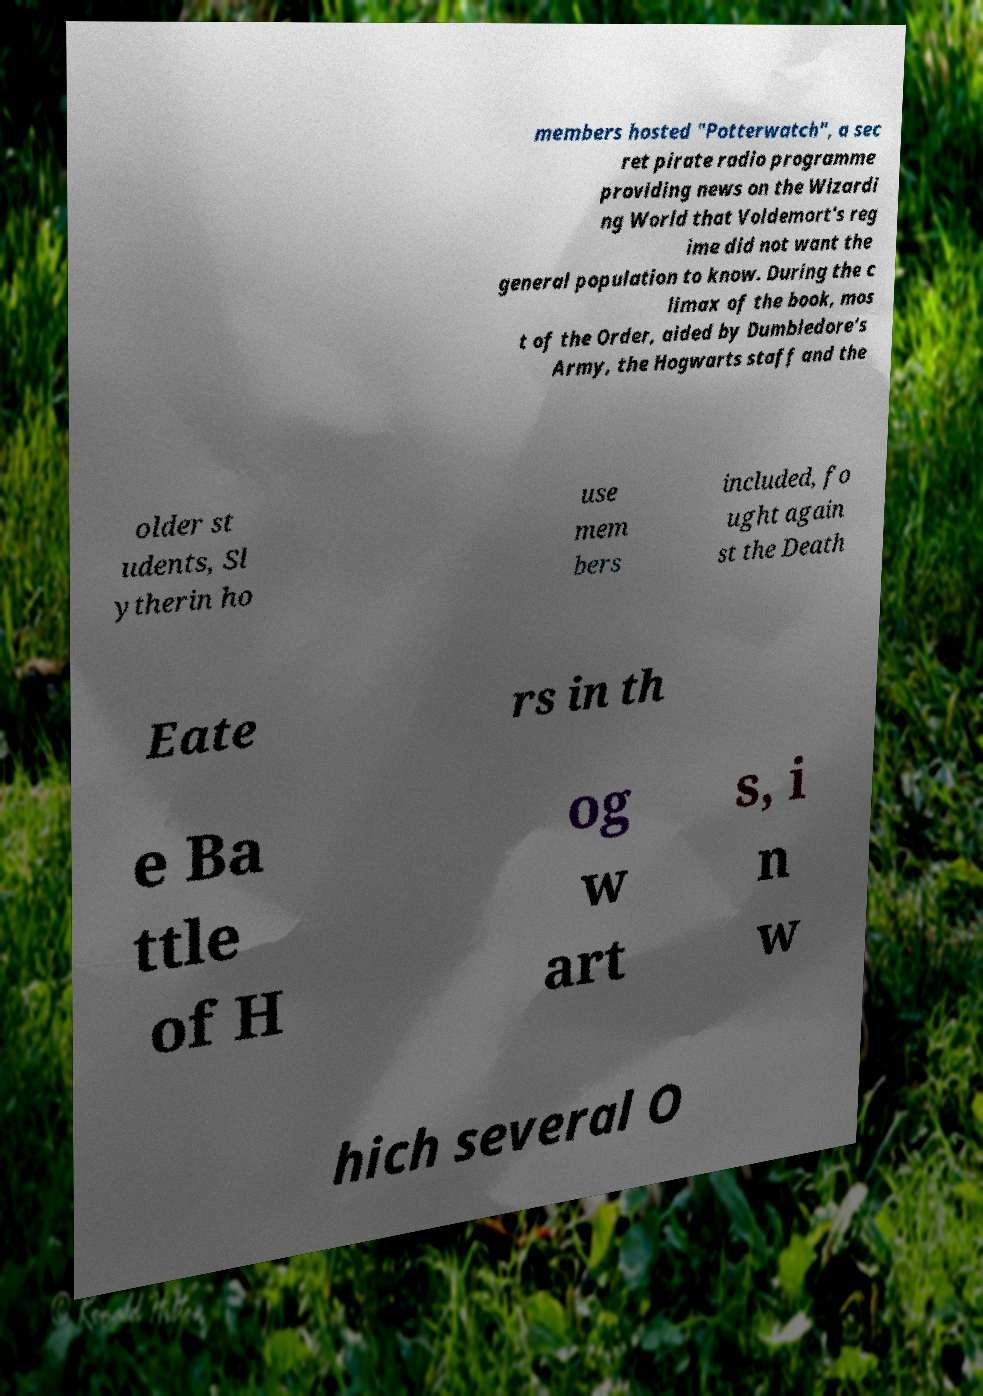What messages or text are displayed in this image? I need them in a readable, typed format. members hosted "Potterwatch", a sec ret pirate radio programme providing news on the Wizardi ng World that Voldemort's reg ime did not want the general population to know. During the c limax of the book, mos t of the Order, aided by Dumbledore's Army, the Hogwarts staff and the older st udents, Sl ytherin ho use mem bers included, fo ught again st the Death Eate rs in th e Ba ttle of H og w art s, i n w hich several O 